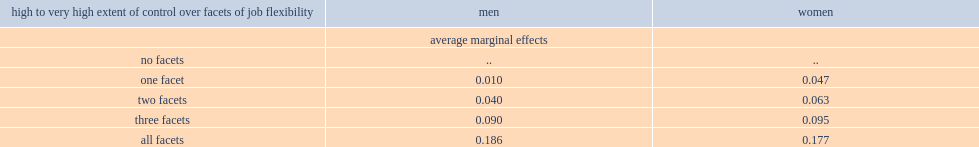For men, how many percent of increasing in the likelihood of being satisfied with their job was associated with having control over three of the four facets of job flexibility in lisa? 0.09. For men, how many percent of increasing in the probability of being satisfied with their job was associated controlling over all facets of job flexibility? 0.186. For women, how many percent of increasing in the probability of being satisfied with their job was associated with controlling over one or two facets of job flexibility. 0.063. For women, how many percent of increasing in the likelihood of being satisfied with their job was associated with having control over three or all four of the facets of job flexibility in lisa? 0.095 0.177. 